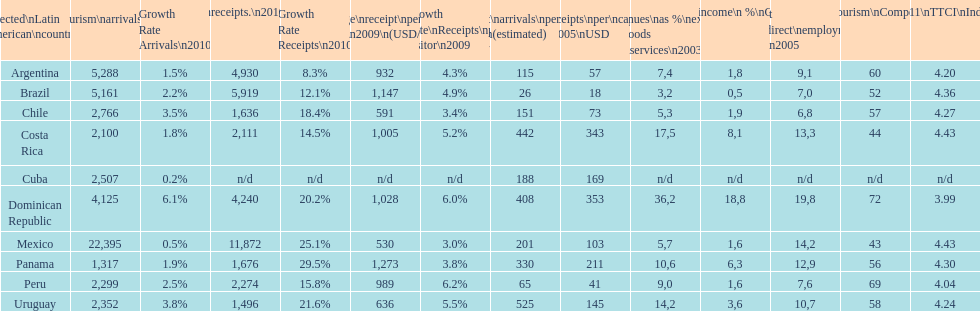Which latin american country had the largest number of tourism arrivals in 2010? Mexico. 